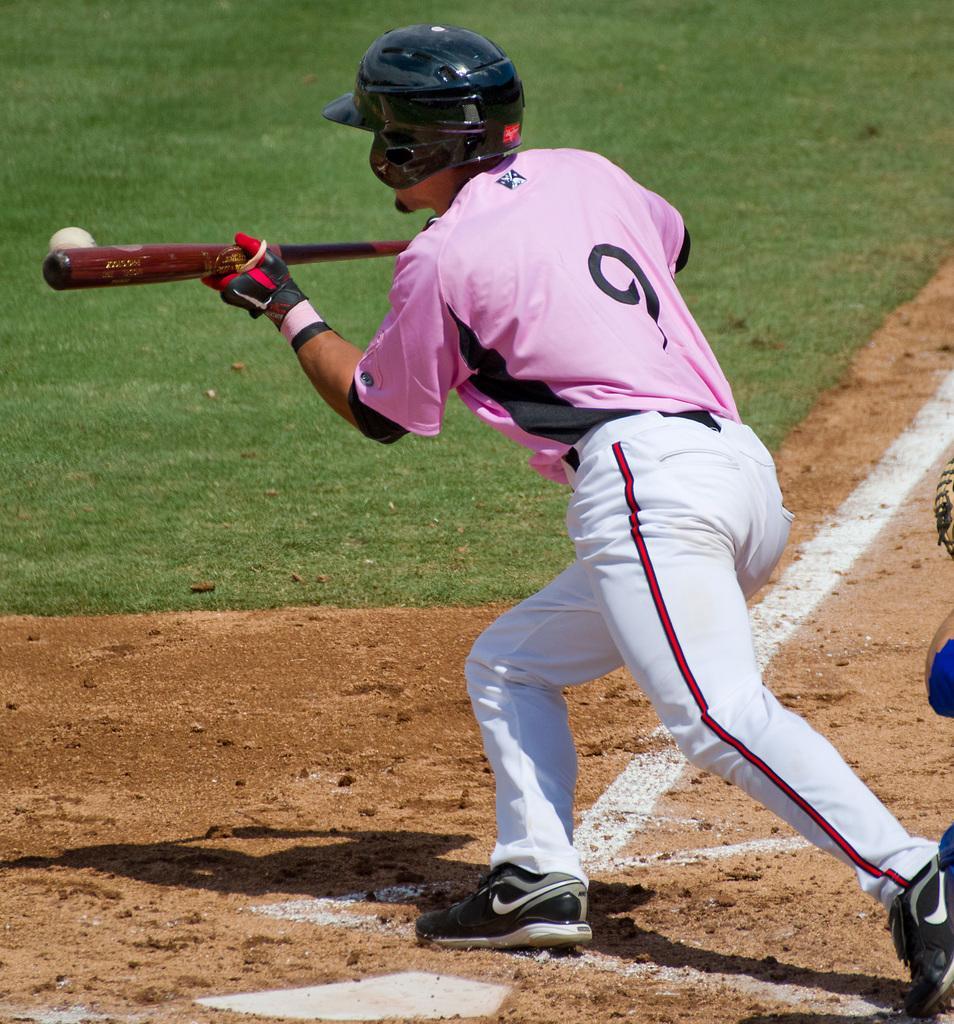How would you summarize this image in a sentence or two? In this image I can see a person is playing the baseball, he wore pink color t-shirt, white color trouser and a black color helmet. 